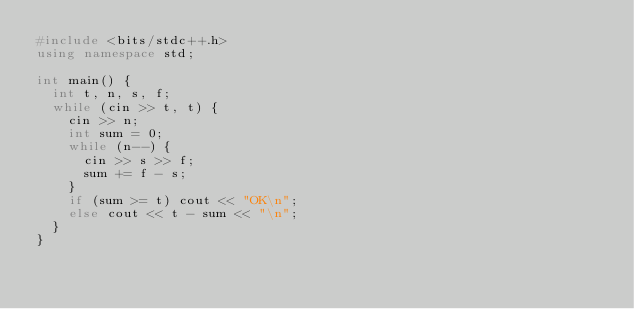<code> <loc_0><loc_0><loc_500><loc_500><_C++_>#include <bits/stdc++.h>
using namespace std;

int main() {
  int t, n, s, f;
  while (cin >> t, t) {
    cin >> n;
    int sum = 0;
    while (n--) {
      cin >> s >> f;
      sum += f - s;
    }
    if (sum >= t) cout << "OK\n";
    else cout << t - sum << "\n";
  }
}
</code> 